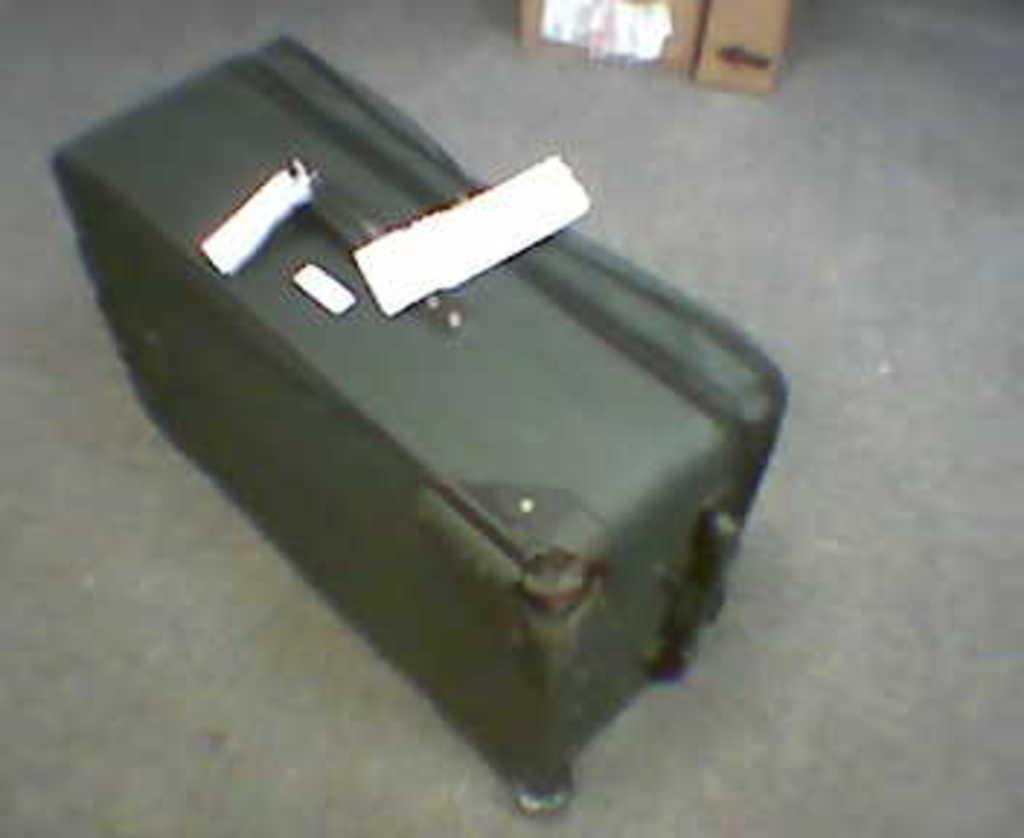What type of bag is on the floor in the image? There is a green traveler bag on the floor. Does the bag have any additional features? Yes, the bag has a tag on it. What other object can be seen in the image? There is a cardboard box in the image. Where is the cardboard box located in relation to the bag? The cardboard box is at the back. What advice does the family give to the actor in the image? There is no family or actor present in the image, so no advice can be given. 